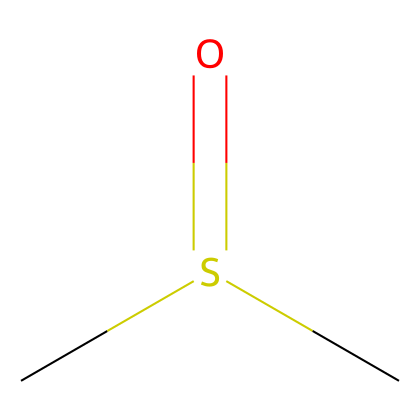What is the molecular formula of this compound? By analyzing the SMILES representation (CS(=O)C), we can identify the elements present. The 'C' stands for carbon, 'S' for sulfur, 'O' for oxygen, and 'H' corresponds to the hydrogen atoms. Counting the components gives us 2 carbon atoms, 6 hydrogen atoms, 1 sulfur atom, and 1 oxygen atom. Therefore, the formula is C2H6OS.
Answer: C2H6OS How many sulfur atoms are present? Looking at the SMILES representation and the overall structure, we see there is one 'S' indicated in the formula. Thus, there is 1 sulfur atom in dimethyl sulfoxide.
Answer: 1 What type of functional group does DMSO contain? The SMILES representation shows a sulfur atom bonded to an oxygen with a double bond (S=O), signifying that it possesses a sulfoxide functional group characterized by the sulfur atom.
Answer: sulfoxide What is the oxidation state of sulfur in this compound? The oxidation state of sulfur can be determined by considering that in DMSO, the sulfur is bonded to two carbon atoms, one oxygen atom (double bond), and overall carries a neutral charge. Given this arrangement, sulfur typically has an oxidation state of +2 in sulfoxides.
Answer: +2 How many hydrogen atoms are bonded to carbon in DMSO? In the SMILES representation, each carbon ('C') is connected to the sulfur and has enough hydrogen atoms to satisfy the tetravalent nature of carbon. One carbon is connected to three hydrogen atoms, while the other carbon is connected to one hydrogen atom. Altogether, there are 6 hydrogen atoms bonded to the two carbon atoms.
Answer: 6 Is dimethyl sulfoxide polar or nonpolar? DMSO has an asymmetric molecular geometry due to the presence of the sulfur-oxygen double bond leading to a significant dipole moment, making it polar in nature.
Answer: polar 